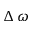<formula> <loc_0><loc_0><loc_500><loc_500>\Delta \, \omega</formula> 